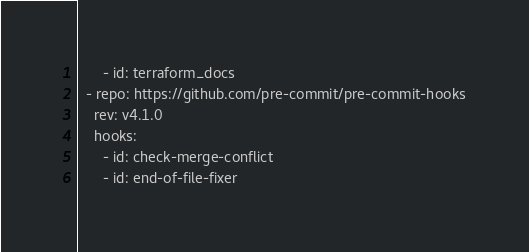<code> <loc_0><loc_0><loc_500><loc_500><_YAML_>      - id: terraform_docs
  - repo: https://github.com/pre-commit/pre-commit-hooks
    rev: v4.1.0
    hooks:
      - id: check-merge-conflict
      - id: end-of-file-fixer
</code> 